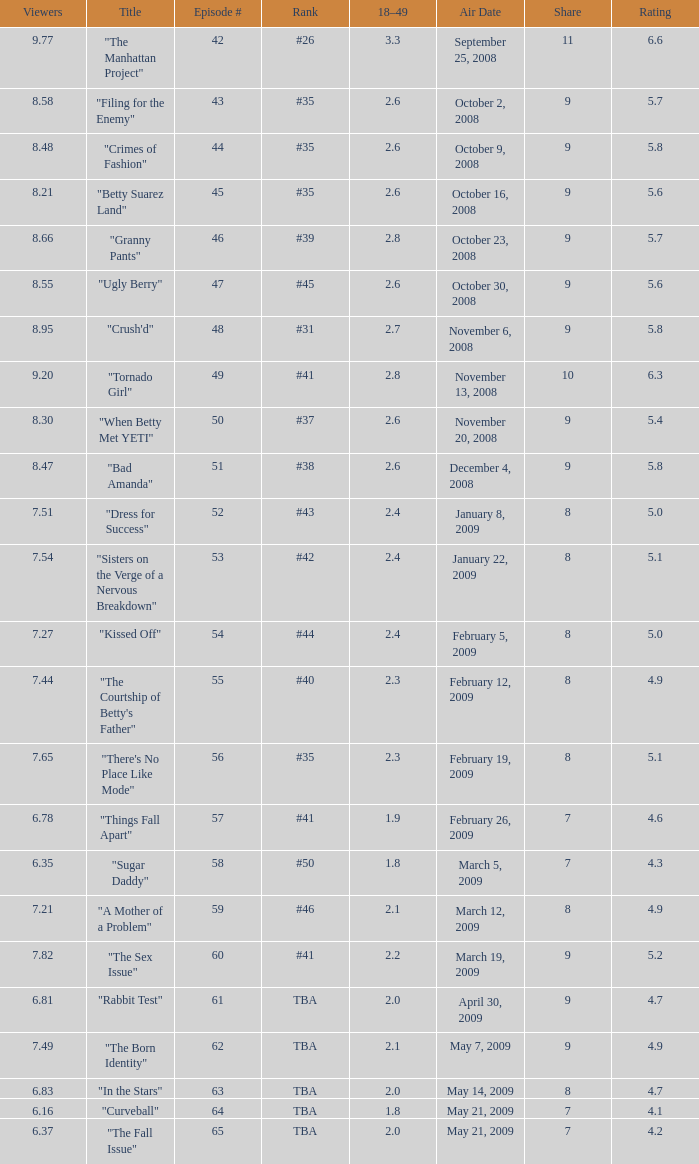What is the average Episode # with a share of 9, and #35 is rank and less than 8.21 viewers? None. 